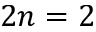<formula> <loc_0><loc_0><loc_500><loc_500>2 n = 2</formula> 